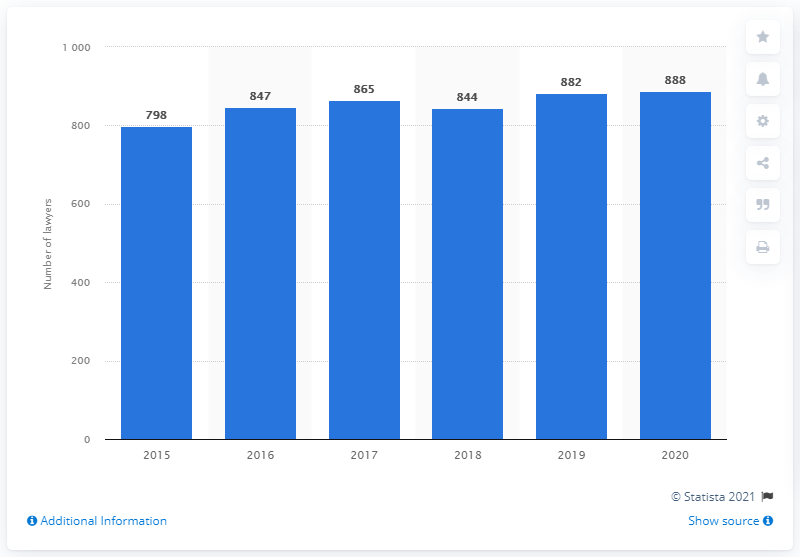Outline some significant characteristics in this image. In 2020, Seyfarth Shaw employed 888 lawyers. 